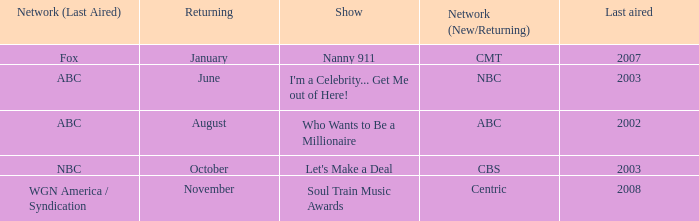When did soul train music awards return? November. 